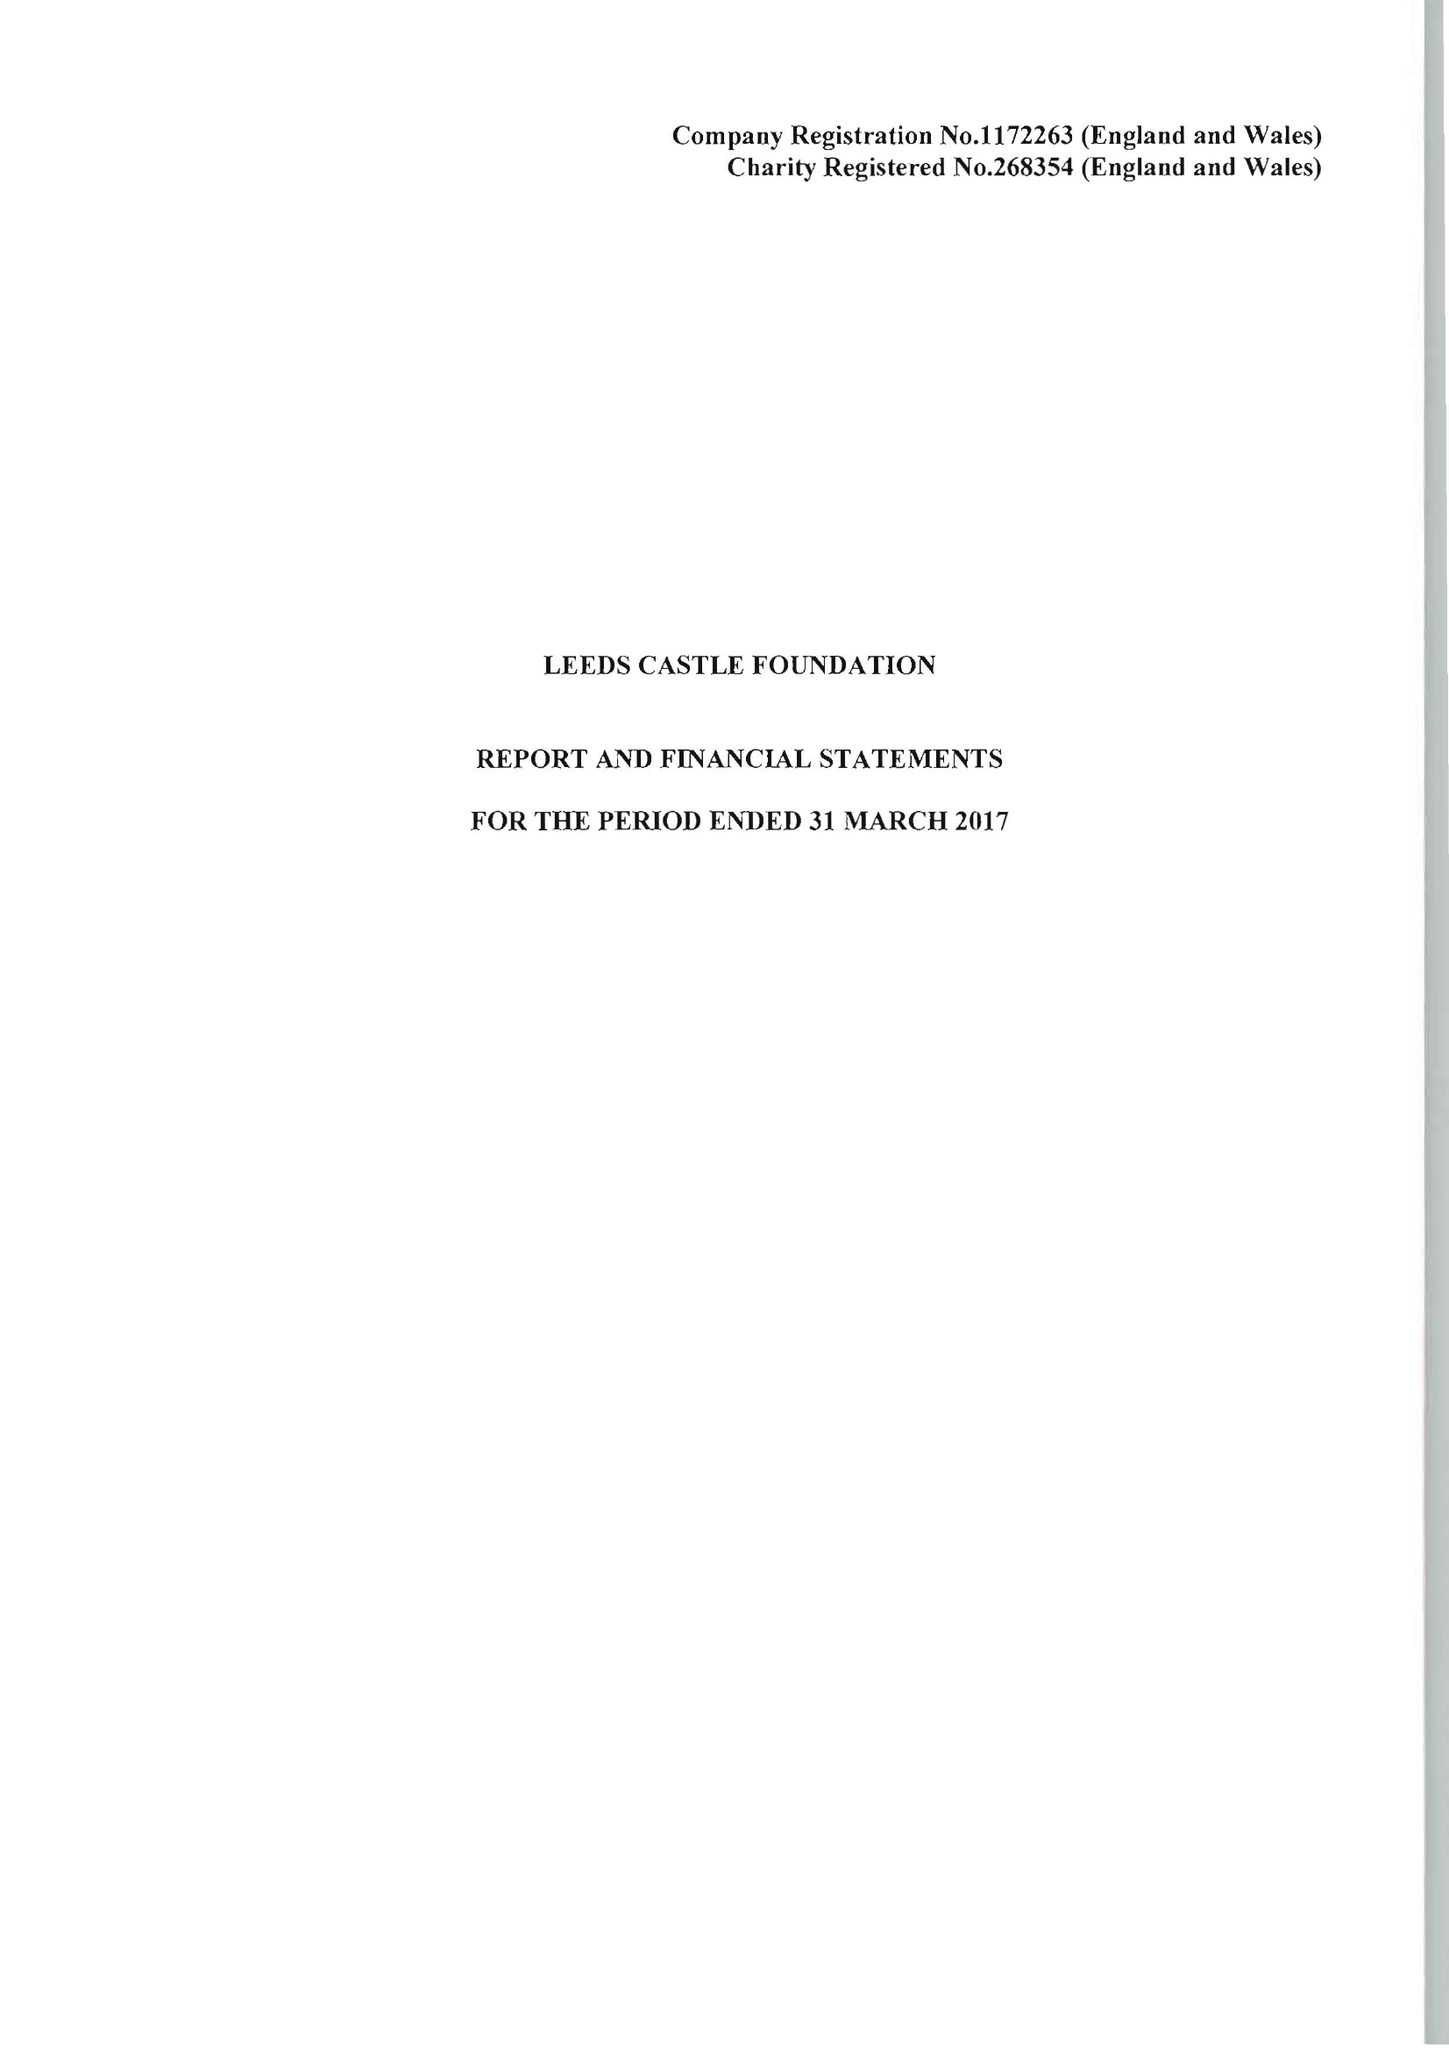What is the value for the spending_annually_in_british_pounds?
Answer the question using a single word or phrase. 10729000.00 